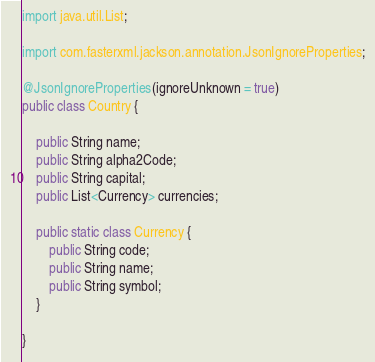<code> <loc_0><loc_0><loc_500><loc_500><_Java_>import java.util.List;

import com.fasterxml.jackson.annotation.JsonIgnoreProperties;

@JsonIgnoreProperties(ignoreUnknown = true)
public class Country {

    public String name;
    public String alpha2Code;
    public String capital;
    public List<Currency> currencies;

    public static class Currency {
        public String code;
        public String name;
        public String symbol;
    }

}
</code> 